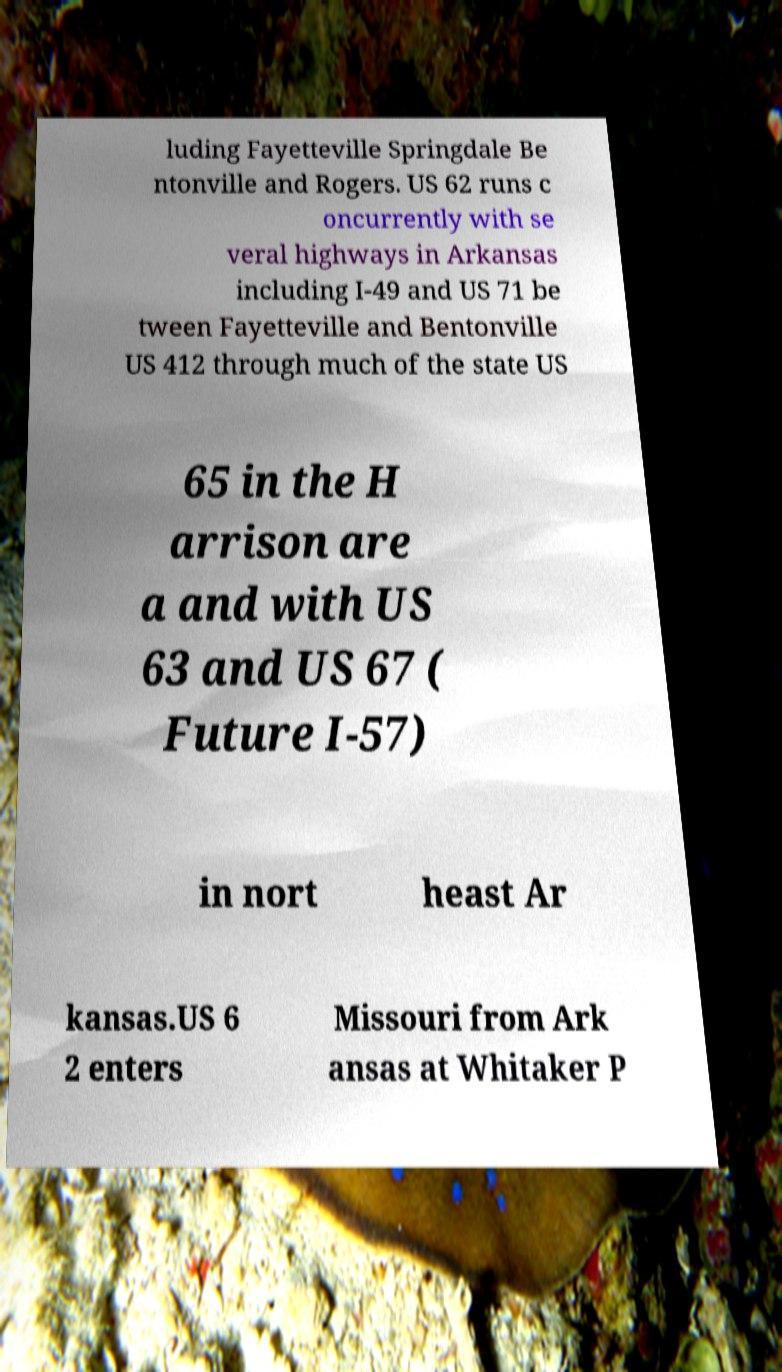Please read and relay the text visible in this image. What does it say? luding Fayetteville Springdale Be ntonville and Rogers. US 62 runs c oncurrently with se veral highways in Arkansas including I-49 and US 71 be tween Fayetteville and Bentonville US 412 through much of the state US 65 in the H arrison are a and with US 63 and US 67 ( Future I-57) in nort heast Ar kansas.US 6 2 enters Missouri from Ark ansas at Whitaker P 